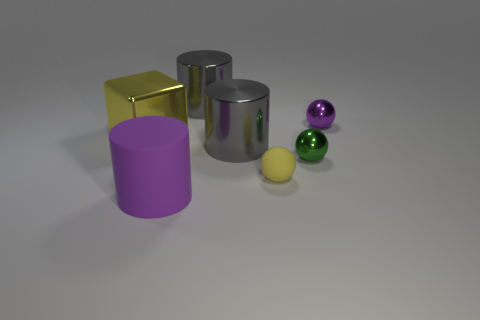What number of small spheres are the same color as the metallic block?
Provide a short and direct response. 1. How many objects are both behind the yellow matte object and on the right side of the yellow metal block?
Keep it short and to the point. 4. What number of tiny gray balls have the same material as the tiny yellow sphere?
Keep it short and to the point. 0. What is the size of the green shiny sphere in front of the big object that is behind the big yellow object?
Ensure brevity in your answer.  Small. Are there any other yellow rubber objects that have the same shape as the small yellow object?
Offer a very short reply. No. Does the purple thing that is to the left of the tiny green thing have the same size as the purple thing that is to the right of the green shiny ball?
Keep it short and to the point. No. Are there fewer purple matte cylinders that are to the right of the small purple shiny thing than cylinders that are on the right side of the small yellow rubber ball?
Offer a terse response. No. There is a thing that is the same color as the big rubber cylinder; what is it made of?
Your answer should be very brief. Metal. What color is the tiny thing behind the large yellow metallic thing?
Your response must be concise. Purple. Do the large shiny cube and the tiny matte ball have the same color?
Your answer should be compact. Yes. 